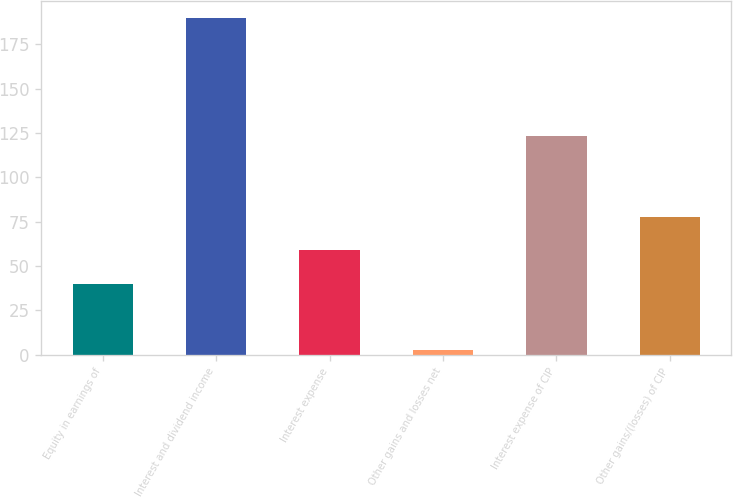Convert chart. <chart><loc_0><loc_0><loc_500><loc_500><bar_chart><fcel>Equity in earnings of<fcel>Interest and dividend income<fcel>Interest expense<fcel>Other gains and losses net<fcel>Interest expense of CIP<fcel>Other gains/(losses) of CIP<nl><fcel>40.08<fcel>190<fcel>58.82<fcel>2.6<fcel>123.3<fcel>77.56<nl></chart> 